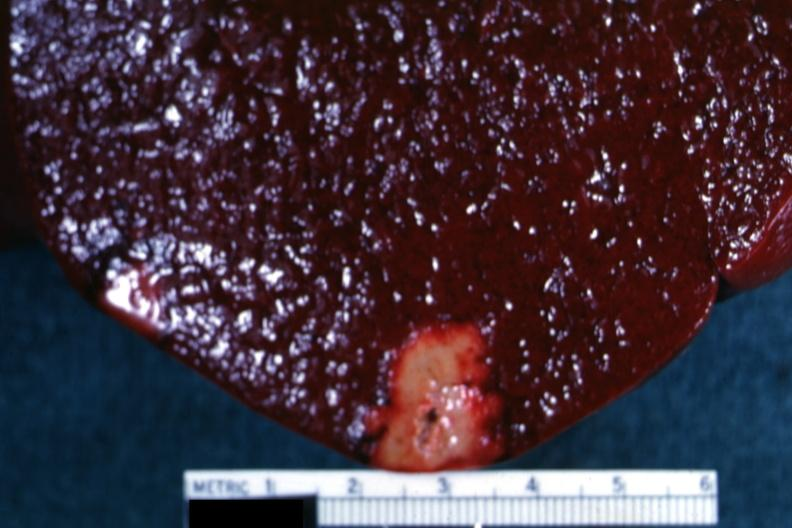s postpartum uterus present?
Answer the question using a single word or phrase. No 